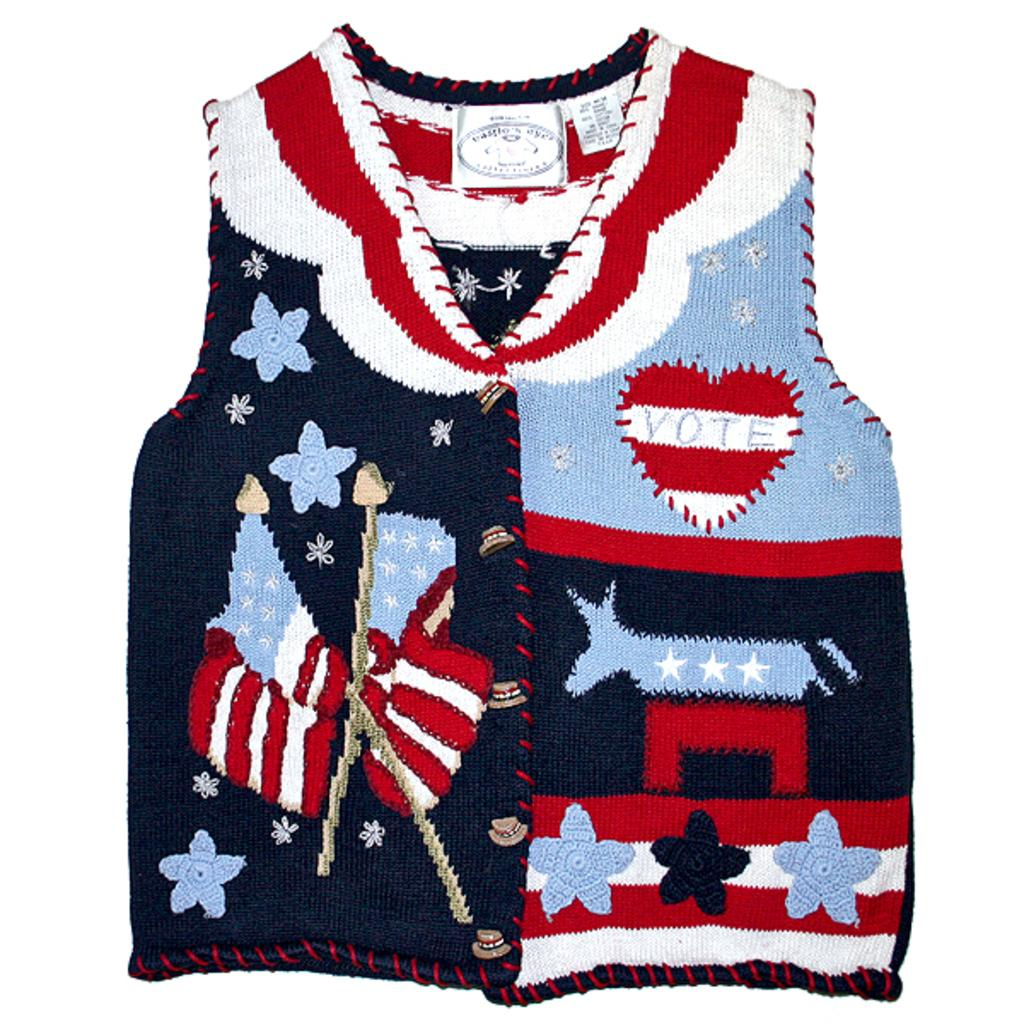<image>
Offer a succinct explanation of the picture presented. A sweater has the word vote on it inside a heart. 